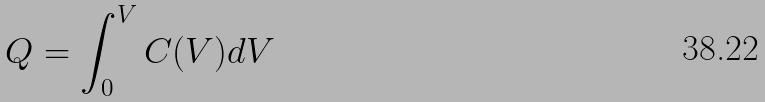<formula> <loc_0><loc_0><loc_500><loc_500>Q = \int _ { 0 } ^ { V } C ( V ) d V</formula> 